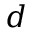Convert formula to latex. <formula><loc_0><loc_0><loc_500><loc_500>d</formula> 